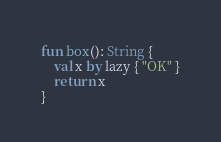<code> <loc_0><loc_0><loc_500><loc_500><_Kotlin_>fun box(): String {
    val x by lazy { "OK" }
    return x
}</code> 